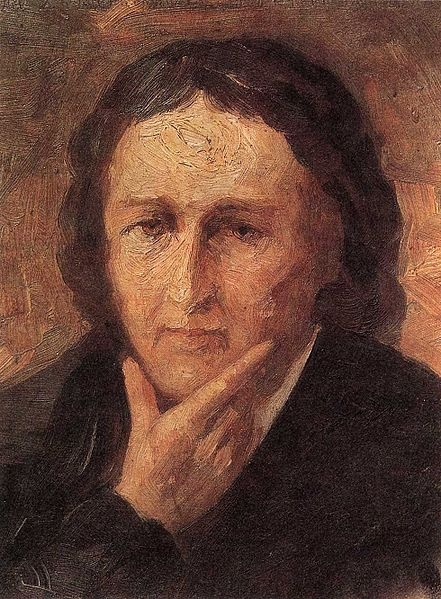What emotions can you infer from the expression of this person? The person in the portrait appears to be deeply pensive or contemplative. Their thoughtful gaze and the way their chin rests on their hand suggest they might be lost in introspection or reflecting on something significant. The somber expression adds a sense of melancholy or seriousness, indicating that they might be grappling with complex emotions or thoughts. 